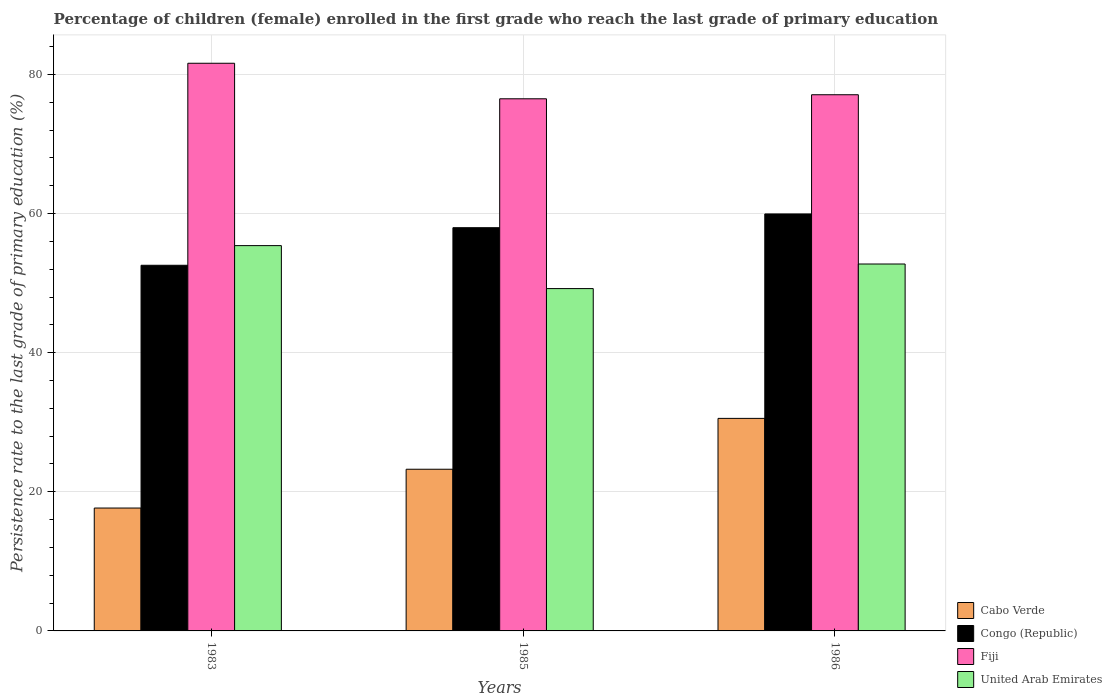Are the number of bars per tick equal to the number of legend labels?
Make the answer very short. Yes. Are the number of bars on each tick of the X-axis equal?
Offer a terse response. Yes. What is the label of the 3rd group of bars from the left?
Give a very brief answer. 1986. In how many cases, is the number of bars for a given year not equal to the number of legend labels?
Make the answer very short. 0. What is the persistence rate of children in Fiji in 1983?
Make the answer very short. 81.6. Across all years, what is the maximum persistence rate of children in United Arab Emirates?
Your response must be concise. 55.39. Across all years, what is the minimum persistence rate of children in Cabo Verde?
Your answer should be compact. 17.66. In which year was the persistence rate of children in United Arab Emirates minimum?
Offer a very short reply. 1985. What is the total persistence rate of children in Fiji in the graph?
Offer a terse response. 235.17. What is the difference between the persistence rate of children in Cabo Verde in 1983 and that in 1986?
Your answer should be very brief. -12.89. What is the difference between the persistence rate of children in United Arab Emirates in 1986 and the persistence rate of children in Cabo Verde in 1983?
Provide a short and direct response. 35.08. What is the average persistence rate of children in United Arab Emirates per year?
Provide a short and direct response. 52.45. In the year 1983, what is the difference between the persistence rate of children in United Arab Emirates and persistence rate of children in Cabo Verde?
Your response must be concise. 37.72. What is the ratio of the persistence rate of children in Congo (Republic) in 1983 to that in 1986?
Keep it short and to the point. 0.88. What is the difference between the highest and the second highest persistence rate of children in Congo (Republic)?
Provide a succinct answer. 1.98. What is the difference between the highest and the lowest persistence rate of children in United Arab Emirates?
Provide a short and direct response. 6.18. In how many years, is the persistence rate of children in Fiji greater than the average persistence rate of children in Fiji taken over all years?
Offer a terse response. 1. What does the 4th bar from the left in 1986 represents?
Offer a very short reply. United Arab Emirates. What does the 2nd bar from the right in 1985 represents?
Offer a very short reply. Fiji. Is it the case that in every year, the sum of the persistence rate of children in Fiji and persistence rate of children in Congo (Republic) is greater than the persistence rate of children in Cabo Verde?
Your response must be concise. Yes. How many bars are there?
Provide a succinct answer. 12. Are all the bars in the graph horizontal?
Keep it short and to the point. No. Where does the legend appear in the graph?
Offer a terse response. Bottom right. How many legend labels are there?
Offer a terse response. 4. How are the legend labels stacked?
Make the answer very short. Vertical. What is the title of the graph?
Keep it short and to the point. Percentage of children (female) enrolled in the first grade who reach the last grade of primary education. What is the label or title of the Y-axis?
Make the answer very short. Persistence rate to the last grade of primary education (%). What is the Persistence rate to the last grade of primary education (%) of Cabo Verde in 1983?
Give a very brief answer. 17.66. What is the Persistence rate to the last grade of primary education (%) in Congo (Republic) in 1983?
Offer a very short reply. 52.56. What is the Persistence rate to the last grade of primary education (%) in Fiji in 1983?
Offer a terse response. 81.6. What is the Persistence rate to the last grade of primary education (%) of United Arab Emirates in 1983?
Your answer should be very brief. 55.39. What is the Persistence rate to the last grade of primary education (%) in Cabo Verde in 1985?
Your answer should be compact. 23.24. What is the Persistence rate to the last grade of primary education (%) in Congo (Republic) in 1985?
Offer a terse response. 57.96. What is the Persistence rate to the last grade of primary education (%) of Fiji in 1985?
Offer a terse response. 76.49. What is the Persistence rate to the last grade of primary education (%) of United Arab Emirates in 1985?
Give a very brief answer. 49.21. What is the Persistence rate to the last grade of primary education (%) of Cabo Verde in 1986?
Provide a short and direct response. 30.55. What is the Persistence rate to the last grade of primary education (%) of Congo (Republic) in 1986?
Provide a short and direct response. 59.94. What is the Persistence rate to the last grade of primary education (%) in Fiji in 1986?
Offer a terse response. 77.08. What is the Persistence rate to the last grade of primary education (%) in United Arab Emirates in 1986?
Your answer should be very brief. 52.74. Across all years, what is the maximum Persistence rate to the last grade of primary education (%) in Cabo Verde?
Ensure brevity in your answer.  30.55. Across all years, what is the maximum Persistence rate to the last grade of primary education (%) in Congo (Republic)?
Give a very brief answer. 59.94. Across all years, what is the maximum Persistence rate to the last grade of primary education (%) of Fiji?
Your answer should be very brief. 81.6. Across all years, what is the maximum Persistence rate to the last grade of primary education (%) in United Arab Emirates?
Your response must be concise. 55.39. Across all years, what is the minimum Persistence rate to the last grade of primary education (%) in Cabo Verde?
Provide a succinct answer. 17.66. Across all years, what is the minimum Persistence rate to the last grade of primary education (%) of Congo (Republic)?
Keep it short and to the point. 52.56. Across all years, what is the minimum Persistence rate to the last grade of primary education (%) of Fiji?
Offer a very short reply. 76.49. Across all years, what is the minimum Persistence rate to the last grade of primary education (%) in United Arab Emirates?
Offer a very short reply. 49.21. What is the total Persistence rate to the last grade of primary education (%) in Cabo Verde in the graph?
Provide a succinct answer. 71.46. What is the total Persistence rate to the last grade of primary education (%) of Congo (Republic) in the graph?
Keep it short and to the point. 170.47. What is the total Persistence rate to the last grade of primary education (%) in Fiji in the graph?
Offer a very short reply. 235.17. What is the total Persistence rate to the last grade of primary education (%) of United Arab Emirates in the graph?
Provide a succinct answer. 157.34. What is the difference between the Persistence rate to the last grade of primary education (%) in Cabo Verde in 1983 and that in 1985?
Offer a terse response. -5.58. What is the difference between the Persistence rate to the last grade of primary education (%) in Congo (Republic) in 1983 and that in 1985?
Your response must be concise. -5.4. What is the difference between the Persistence rate to the last grade of primary education (%) of Fiji in 1983 and that in 1985?
Your response must be concise. 5.11. What is the difference between the Persistence rate to the last grade of primary education (%) in United Arab Emirates in 1983 and that in 1985?
Make the answer very short. 6.18. What is the difference between the Persistence rate to the last grade of primary education (%) of Cabo Verde in 1983 and that in 1986?
Your answer should be very brief. -12.89. What is the difference between the Persistence rate to the last grade of primary education (%) in Congo (Republic) in 1983 and that in 1986?
Offer a very short reply. -7.38. What is the difference between the Persistence rate to the last grade of primary education (%) of Fiji in 1983 and that in 1986?
Make the answer very short. 4.53. What is the difference between the Persistence rate to the last grade of primary education (%) of United Arab Emirates in 1983 and that in 1986?
Offer a terse response. 2.64. What is the difference between the Persistence rate to the last grade of primary education (%) of Cabo Verde in 1985 and that in 1986?
Your answer should be very brief. -7.31. What is the difference between the Persistence rate to the last grade of primary education (%) in Congo (Republic) in 1985 and that in 1986?
Your response must be concise. -1.98. What is the difference between the Persistence rate to the last grade of primary education (%) in Fiji in 1985 and that in 1986?
Your answer should be very brief. -0.58. What is the difference between the Persistence rate to the last grade of primary education (%) of United Arab Emirates in 1985 and that in 1986?
Your response must be concise. -3.53. What is the difference between the Persistence rate to the last grade of primary education (%) of Cabo Verde in 1983 and the Persistence rate to the last grade of primary education (%) of Congo (Republic) in 1985?
Offer a very short reply. -40.3. What is the difference between the Persistence rate to the last grade of primary education (%) in Cabo Verde in 1983 and the Persistence rate to the last grade of primary education (%) in Fiji in 1985?
Keep it short and to the point. -58.83. What is the difference between the Persistence rate to the last grade of primary education (%) in Cabo Verde in 1983 and the Persistence rate to the last grade of primary education (%) in United Arab Emirates in 1985?
Provide a succinct answer. -31.55. What is the difference between the Persistence rate to the last grade of primary education (%) of Congo (Republic) in 1983 and the Persistence rate to the last grade of primary education (%) of Fiji in 1985?
Keep it short and to the point. -23.93. What is the difference between the Persistence rate to the last grade of primary education (%) of Congo (Republic) in 1983 and the Persistence rate to the last grade of primary education (%) of United Arab Emirates in 1985?
Ensure brevity in your answer.  3.35. What is the difference between the Persistence rate to the last grade of primary education (%) of Fiji in 1983 and the Persistence rate to the last grade of primary education (%) of United Arab Emirates in 1985?
Provide a short and direct response. 32.39. What is the difference between the Persistence rate to the last grade of primary education (%) in Cabo Verde in 1983 and the Persistence rate to the last grade of primary education (%) in Congo (Republic) in 1986?
Provide a short and direct response. -42.28. What is the difference between the Persistence rate to the last grade of primary education (%) in Cabo Verde in 1983 and the Persistence rate to the last grade of primary education (%) in Fiji in 1986?
Provide a succinct answer. -59.41. What is the difference between the Persistence rate to the last grade of primary education (%) in Cabo Verde in 1983 and the Persistence rate to the last grade of primary education (%) in United Arab Emirates in 1986?
Provide a succinct answer. -35.08. What is the difference between the Persistence rate to the last grade of primary education (%) in Congo (Republic) in 1983 and the Persistence rate to the last grade of primary education (%) in Fiji in 1986?
Offer a terse response. -24.51. What is the difference between the Persistence rate to the last grade of primary education (%) in Congo (Republic) in 1983 and the Persistence rate to the last grade of primary education (%) in United Arab Emirates in 1986?
Keep it short and to the point. -0.18. What is the difference between the Persistence rate to the last grade of primary education (%) of Fiji in 1983 and the Persistence rate to the last grade of primary education (%) of United Arab Emirates in 1986?
Your answer should be very brief. 28.86. What is the difference between the Persistence rate to the last grade of primary education (%) in Cabo Verde in 1985 and the Persistence rate to the last grade of primary education (%) in Congo (Republic) in 1986?
Keep it short and to the point. -36.7. What is the difference between the Persistence rate to the last grade of primary education (%) of Cabo Verde in 1985 and the Persistence rate to the last grade of primary education (%) of Fiji in 1986?
Provide a short and direct response. -53.83. What is the difference between the Persistence rate to the last grade of primary education (%) of Cabo Verde in 1985 and the Persistence rate to the last grade of primary education (%) of United Arab Emirates in 1986?
Provide a short and direct response. -29.5. What is the difference between the Persistence rate to the last grade of primary education (%) in Congo (Republic) in 1985 and the Persistence rate to the last grade of primary education (%) in Fiji in 1986?
Give a very brief answer. -19.11. What is the difference between the Persistence rate to the last grade of primary education (%) of Congo (Republic) in 1985 and the Persistence rate to the last grade of primary education (%) of United Arab Emirates in 1986?
Ensure brevity in your answer.  5.22. What is the difference between the Persistence rate to the last grade of primary education (%) in Fiji in 1985 and the Persistence rate to the last grade of primary education (%) in United Arab Emirates in 1986?
Keep it short and to the point. 23.75. What is the average Persistence rate to the last grade of primary education (%) in Cabo Verde per year?
Make the answer very short. 23.82. What is the average Persistence rate to the last grade of primary education (%) in Congo (Republic) per year?
Provide a succinct answer. 56.82. What is the average Persistence rate to the last grade of primary education (%) in Fiji per year?
Give a very brief answer. 78.39. What is the average Persistence rate to the last grade of primary education (%) of United Arab Emirates per year?
Your answer should be compact. 52.45. In the year 1983, what is the difference between the Persistence rate to the last grade of primary education (%) of Cabo Verde and Persistence rate to the last grade of primary education (%) of Congo (Republic)?
Provide a short and direct response. -34.9. In the year 1983, what is the difference between the Persistence rate to the last grade of primary education (%) in Cabo Verde and Persistence rate to the last grade of primary education (%) in Fiji?
Keep it short and to the point. -63.94. In the year 1983, what is the difference between the Persistence rate to the last grade of primary education (%) in Cabo Verde and Persistence rate to the last grade of primary education (%) in United Arab Emirates?
Give a very brief answer. -37.72. In the year 1983, what is the difference between the Persistence rate to the last grade of primary education (%) of Congo (Republic) and Persistence rate to the last grade of primary education (%) of Fiji?
Offer a terse response. -29.04. In the year 1983, what is the difference between the Persistence rate to the last grade of primary education (%) of Congo (Republic) and Persistence rate to the last grade of primary education (%) of United Arab Emirates?
Your answer should be compact. -2.82. In the year 1983, what is the difference between the Persistence rate to the last grade of primary education (%) in Fiji and Persistence rate to the last grade of primary education (%) in United Arab Emirates?
Keep it short and to the point. 26.22. In the year 1985, what is the difference between the Persistence rate to the last grade of primary education (%) of Cabo Verde and Persistence rate to the last grade of primary education (%) of Congo (Republic)?
Offer a very short reply. -34.72. In the year 1985, what is the difference between the Persistence rate to the last grade of primary education (%) of Cabo Verde and Persistence rate to the last grade of primary education (%) of Fiji?
Give a very brief answer. -53.25. In the year 1985, what is the difference between the Persistence rate to the last grade of primary education (%) of Cabo Verde and Persistence rate to the last grade of primary education (%) of United Arab Emirates?
Provide a short and direct response. -25.97. In the year 1985, what is the difference between the Persistence rate to the last grade of primary education (%) of Congo (Republic) and Persistence rate to the last grade of primary education (%) of Fiji?
Your response must be concise. -18.53. In the year 1985, what is the difference between the Persistence rate to the last grade of primary education (%) in Congo (Republic) and Persistence rate to the last grade of primary education (%) in United Arab Emirates?
Your answer should be compact. 8.75. In the year 1985, what is the difference between the Persistence rate to the last grade of primary education (%) in Fiji and Persistence rate to the last grade of primary education (%) in United Arab Emirates?
Provide a succinct answer. 27.29. In the year 1986, what is the difference between the Persistence rate to the last grade of primary education (%) in Cabo Verde and Persistence rate to the last grade of primary education (%) in Congo (Republic)?
Give a very brief answer. -29.39. In the year 1986, what is the difference between the Persistence rate to the last grade of primary education (%) of Cabo Verde and Persistence rate to the last grade of primary education (%) of Fiji?
Your answer should be very brief. -46.52. In the year 1986, what is the difference between the Persistence rate to the last grade of primary education (%) in Cabo Verde and Persistence rate to the last grade of primary education (%) in United Arab Emirates?
Keep it short and to the point. -22.19. In the year 1986, what is the difference between the Persistence rate to the last grade of primary education (%) of Congo (Republic) and Persistence rate to the last grade of primary education (%) of Fiji?
Ensure brevity in your answer.  -17.14. In the year 1986, what is the difference between the Persistence rate to the last grade of primary education (%) of Congo (Republic) and Persistence rate to the last grade of primary education (%) of United Arab Emirates?
Provide a short and direct response. 7.2. In the year 1986, what is the difference between the Persistence rate to the last grade of primary education (%) in Fiji and Persistence rate to the last grade of primary education (%) in United Arab Emirates?
Your answer should be very brief. 24.33. What is the ratio of the Persistence rate to the last grade of primary education (%) in Cabo Verde in 1983 to that in 1985?
Your response must be concise. 0.76. What is the ratio of the Persistence rate to the last grade of primary education (%) of Congo (Republic) in 1983 to that in 1985?
Your answer should be very brief. 0.91. What is the ratio of the Persistence rate to the last grade of primary education (%) in Fiji in 1983 to that in 1985?
Make the answer very short. 1.07. What is the ratio of the Persistence rate to the last grade of primary education (%) of United Arab Emirates in 1983 to that in 1985?
Keep it short and to the point. 1.13. What is the ratio of the Persistence rate to the last grade of primary education (%) of Cabo Verde in 1983 to that in 1986?
Ensure brevity in your answer.  0.58. What is the ratio of the Persistence rate to the last grade of primary education (%) in Congo (Republic) in 1983 to that in 1986?
Offer a terse response. 0.88. What is the ratio of the Persistence rate to the last grade of primary education (%) in Fiji in 1983 to that in 1986?
Ensure brevity in your answer.  1.06. What is the ratio of the Persistence rate to the last grade of primary education (%) of United Arab Emirates in 1983 to that in 1986?
Provide a succinct answer. 1.05. What is the ratio of the Persistence rate to the last grade of primary education (%) of Cabo Verde in 1985 to that in 1986?
Offer a very short reply. 0.76. What is the ratio of the Persistence rate to the last grade of primary education (%) of Fiji in 1985 to that in 1986?
Offer a terse response. 0.99. What is the ratio of the Persistence rate to the last grade of primary education (%) of United Arab Emirates in 1985 to that in 1986?
Provide a short and direct response. 0.93. What is the difference between the highest and the second highest Persistence rate to the last grade of primary education (%) in Cabo Verde?
Offer a terse response. 7.31. What is the difference between the highest and the second highest Persistence rate to the last grade of primary education (%) of Congo (Republic)?
Provide a succinct answer. 1.98. What is the difference between the highest and the second highest Persistence rate to the last grade of primary education (%) in Fiji?
Offer a terse response. 4.53. What is the difference between the highest and the second highest Persistence rate to the last grade of primary education (%) in United Arab Emirates?
Offer a terse response. 2.64. What is the difference between the highest and the lowest Persistence rate to the last grade of primary education (%) in Cabo Verde?
Provide a short and direct response. 12.89. What is the difference between the highest and the lowest Persistence rate to the last grade of primary education (%) of Congo (Republic)?
Offer a very short reply. 7.38. What is the difference between the highest and the lowest Persistence rate to the last grade of primary education (%) of Fiji?
Offer a very short reply. 5.11. What is the difference between the highest and the lowest Persistence rate to the last grade of primary education (%) in United Arab Emirates?
Keep it short and to the point. 6.18. 